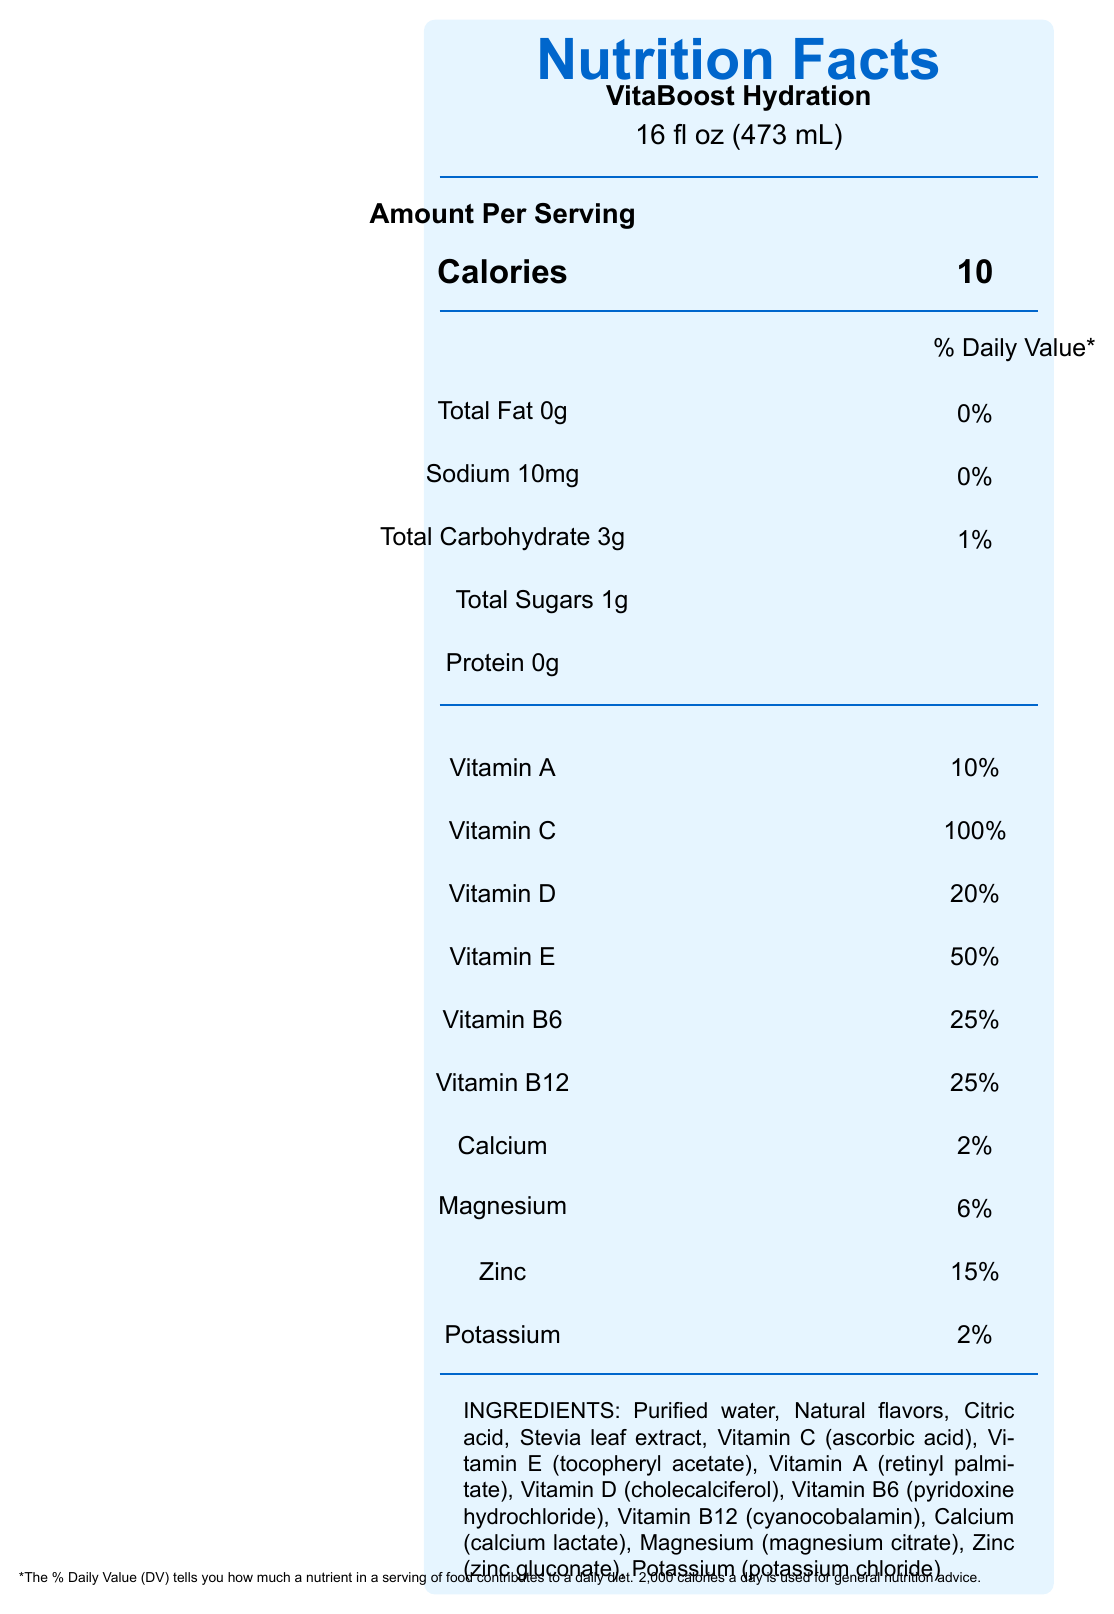what is the serving size of VitaBoost Hydration? The document states that the serving size for VitaBoost Hydration is 16 fl oz (473 mL).
Answer: 16 fl oz (473 mL) How many calories are in one serving of VitaBoost Hydration? According to the nutrition facts, one serving of VitaBoost Hydration contains 10 calories.
Answer: 10 List three key vitamins and their daily value percentages in VitaBoost Hydration. The document lists Vitamin C with 100% DV, Vitamin E with 50% DV, and Vitamin B6 with 25% DV.
Answer: Vitamin C (100%), Vitamin E (50%), Vitamin B6 (25%) What are the total carbohydrates in one serving of VitaBoost Hydration? The document specifies that the total carbohydrate content in one serving is 3g.
Answer: 3g What is the annual cost of consuming one bottle of VitaBoost Hydration per day? The document provides an annual consumption estimate of 365 bottles, resulting in an annual cost of $909.85.
Answer: $909.85 What percentage of the daily value of protein does VitaBoost Hydration contain? A. 0% B. 1% C. 2% D. 5% The nutrition facts label shows that VitaBoost Hydration contains 0% daily value of protein.
Answer: A. 0% Which of the following is NOT an ingredient in VitaBoost Hydration? A. Stevia leaf extract B. Citric acid C. High fructose corn syrup D. Magnesium citrate The ingredient list does not include high fructose corn syrup; this is not an ingredient in VitaBoost Hydration.
Answer: C. High fructose corn syrup Does VitaBoost Hydration contain any fat? The nutrition facts label indicates that the total fat content is 0g, meaning there is no fat in VitaBoost Hydration.
Answer: No Summarize the main idea of the document. The document is a comprehensive overview of VitaBoost Hydration's nutritional information, economic implications, and potential benefits and costs associated with its consumption, comparing it against standard tap water financially and environmentally.
Answer: The document provides detailed nutrition facts for VitaBoost Hydration, a vitamin-enriched water beverage. It includes nutritional content per serving, ingredients, costs, and a long-term cost analysis comparing VitaBoost Hydration to tap water. Additionally, it outlines potential health benefits, financial considerations, and environmental impacts. What is the expected five-year value of investing the cost difference between VitaBoost Hydration and tap water annually? The document estimates the five-year value of investing the $4541.75 cost difference between the two at an annual return of 7%, which amounts to $6372.45.
Answer: $6372.45 What is the carbon footprint increase attributed to VitaBoost Hydration? The document notes that the carbon footprint increase related to VitaBoost Hydration is moderate because of production and transportation.
Answer: Moderate due to production and transportation What financial consideration should be taken into account due to the higher cost of VitaBoost Hydration compared to tap water? The document mentions that the higher cost should be considered in terms of its impact on the monthly budget and long-term savings goals.
Answer: Impact on monthly budget and long-term savings goals How much plastic waste is generated annually by consuming VitaBoost Hydration according to the document? The document states that consuming one bottle per day for a year results in 365 plastic bottles as waste.
Answer: 365 bottles Which vitamin in VitaBoost Hydration has the highest daily value percentage? The document lists Vitamin C at 100%, which is the highest daily value percentage among the listed vitamins.
Answer: Vitamin C What is the cost difference over five years between VitaBoost Hydration and tap water? The document specifies that the cost difference over five years between consuming VitaBoost Hydration and tap water is $4541.75.
Answer: $4541.75 What is the opportunity cost of not investing the difference in price between VitaBoost Hydration and tap water over five years? The document states that investing the cost difference in a low-cost index fund with a 7% expected annual return could potentially grow to $6372.45 over five years. This reflects the opportunity cost.
Answer: $6372.45 